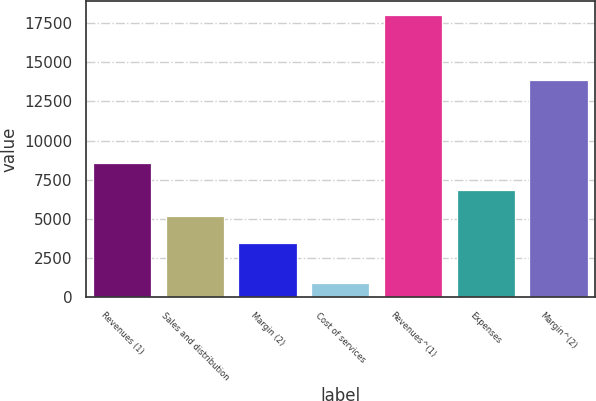<chart> <loc_0><loc_0><loc_500><loc_500><bar_chart><fcel>Revenues (1)<fcel>Sales and distribution<fcel>Margin (2)<fcel>Cost of services<fcel>Revenues^(1)<fcel>Expenses<fcel>Margin^(2)<nl><fcel>8583.5<fcel>5168.5<fcel>3461<fcel>933<fcel>18008<fcel>6876<fcel>13839<nl></chart> 